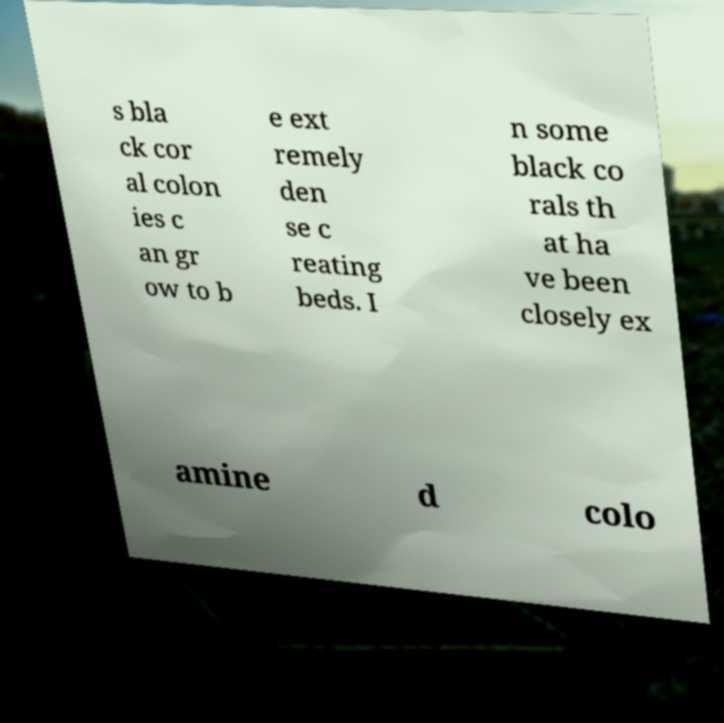There's text embedded in this image that I need extracted. Can you transcribe it verbatim? s bla ck cor al colon ies c an gr ow to b e ext remely den se c reating beds. I n some black co rals th at ha ve been closely ex amine d colo 